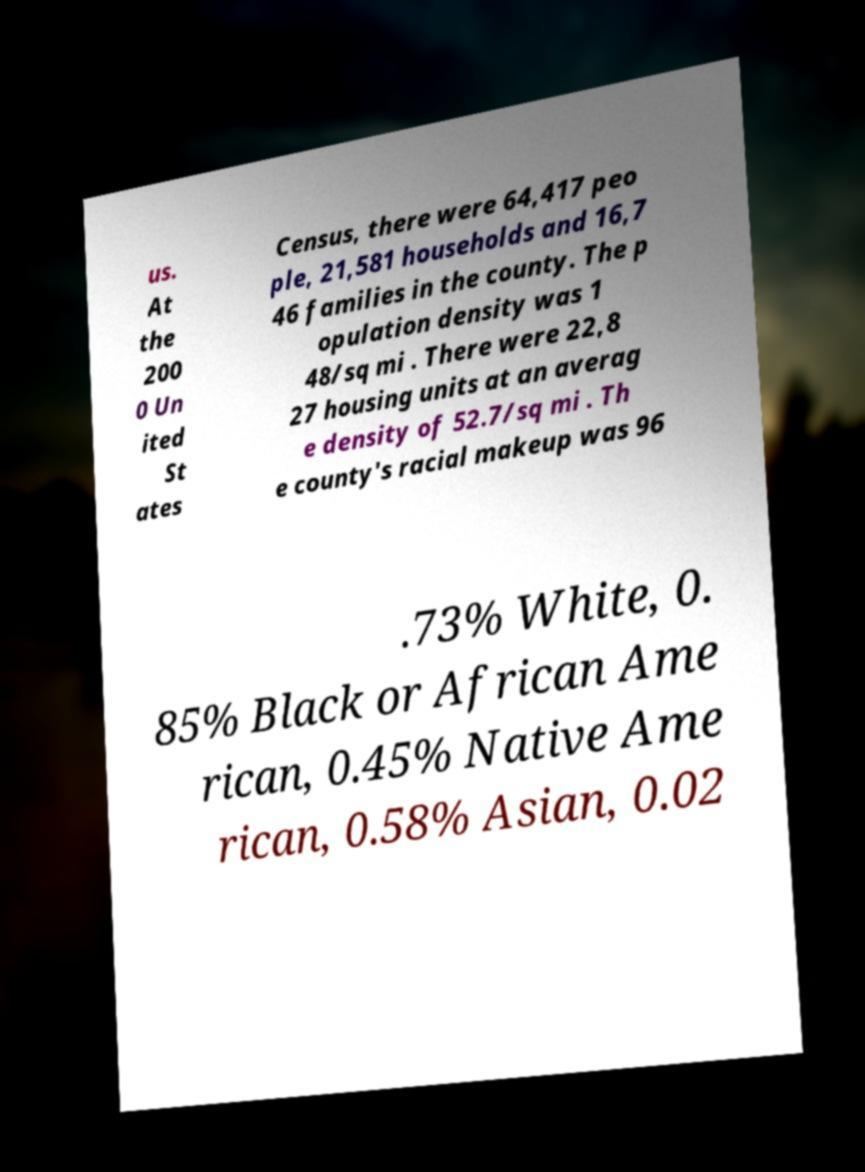Please read and relay the text visible in this image. What does it say? us. At the 200 0 Un ited St ates Census, there were 64,417 peo ple, 21,581 households and 16,7 46 families in the county. The p opulation density was 1 48/sq mi . There were 22,8 27 housing units at an averag e density of 52.7/sq mi . Th e county's racial makeup was 96 .73% White, 0. 85% Black or African Ame rican, 0.45% Native Ame rican, 0.58% Asian, 0.02 